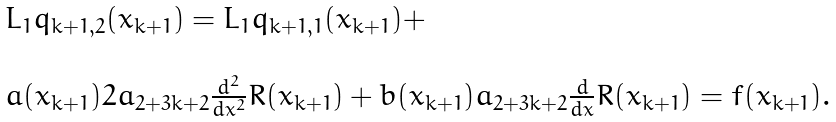<formula> <loc_0><loc_0><loc_500><loc_500>\begin{array} { l l } L _ { 1 } q _ { k + 1 , 2 } ( x _ { k + 1 } ) = L _ { 1 } q _ { k + 1 , 1 } ( x _ { k + 1 } ) + \\ \\ a ( x _ { k + 1 } ) 2 a _ { 2 + 3 k + 2 } \frac { d ^ { 2 } } { d x ^ { 2 } } R ( x _ { k + 1 } ) + b ( x _ { k + 1 } ) a _ { 2 + 3 k + 2 } \frac { d } { d x } R ( x _ { k + 1 } ) = f ( x _ { k + 1 } ) . \end{array}</formula> 